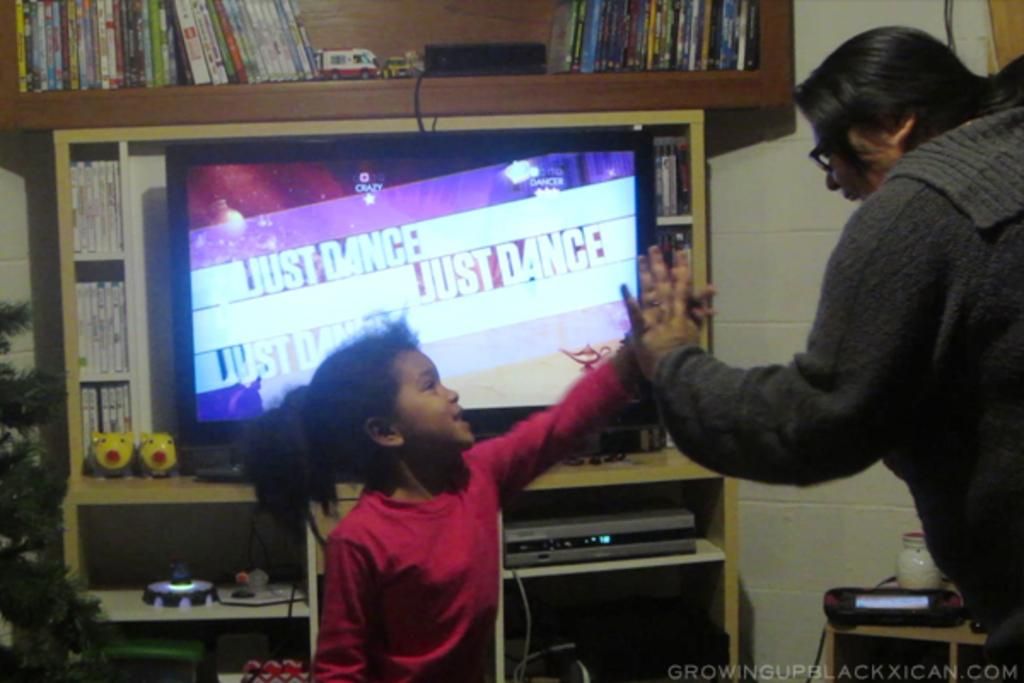How many people are in the image? There are two persons in the image. What electronic device can be seen in the image? There is a television in the image. What type of items are present in the image? There are books, objects in racks, and objects on a table in the image. Where is the plant located in the image? The plant is on the left side of the image. What type of land can be seen in the image? There is no land visible in the image; it features two persons, a television, books, objects in racks, objects on a table, and a plant. Is the moon visible in the image? No, the moon is not visible in the image. 